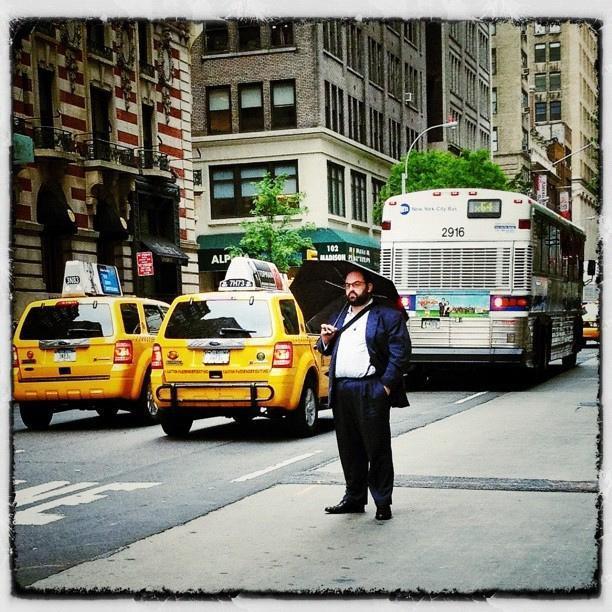How many cars are visible?
Give a very brief answer. 2. 